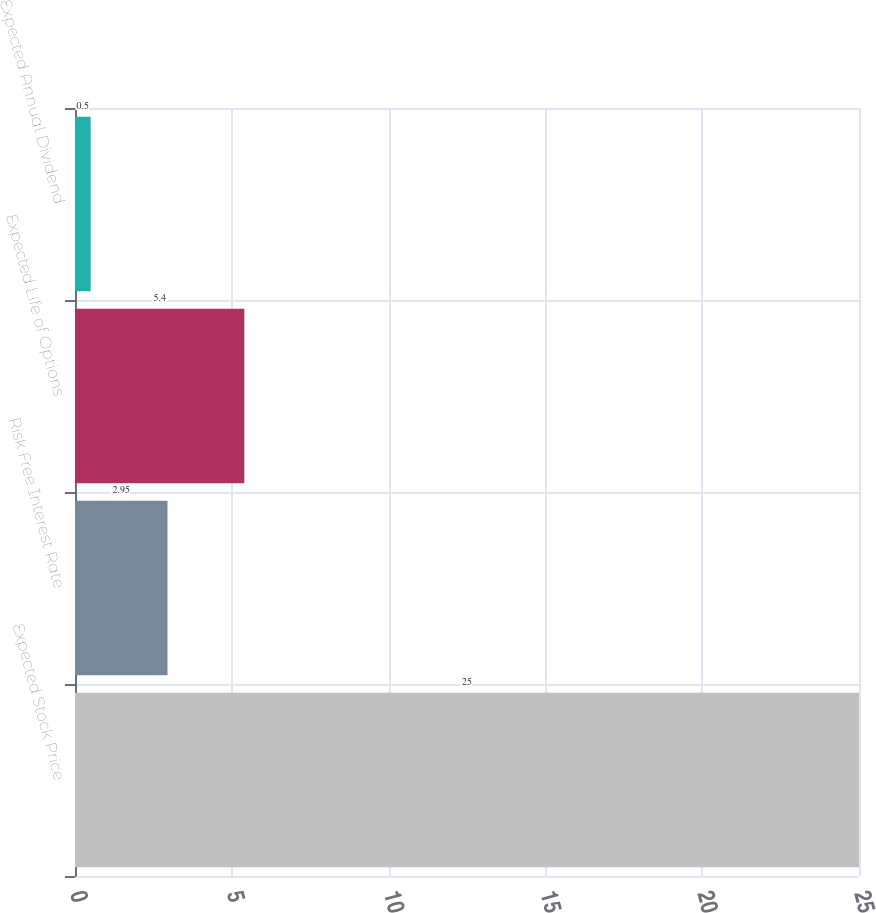Convert chart. <chart><loc_0><loc_0><loc_500><loc_500><bar_chart><fcel>Expected Stock Price<fcel>Risk Free Interest Rate<fcel>Expected Life of Options<fcel>Expected Annual Dividend<nl><fcel>25<fcel>2.95<fcel>5.4<fcel>0.5<nl></chart> 